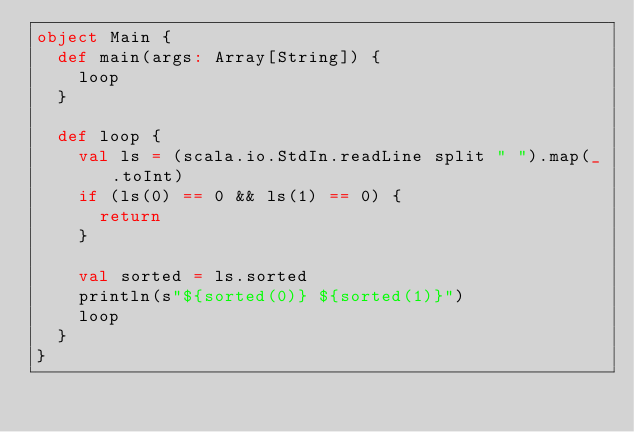<code> <loc_0><loc_0><loc_500><loc_500><_Scala_>object Main {
  def main(args: Array[String]) {
    loop
  }

  def loop {
    val ls = (scala.io.StdIn.readLine split " ").map(_.toInt)
    if (ls(0) == 0 && ls(1) == 0) {
      return
    }

    val sorted = ls.sorted
    println(s"${sorted(0)} ${sorted(1)}")
    loop
  }
}</code> 